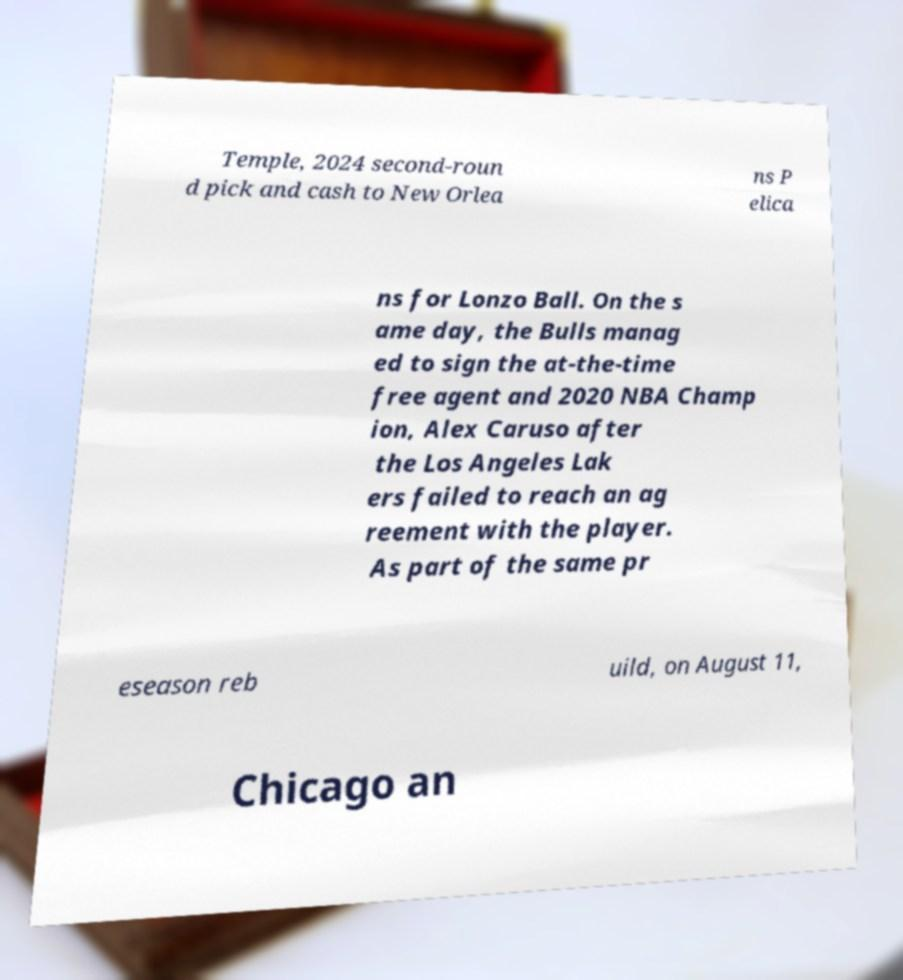What messages or text are displayed in this image? I need them in a readable, typed format. Temple, 2024 second-roun d pick and cash to New Orlea ns P elica ns for Lonzo Ball. On the s ame day, the Bulls manag ed to sign the at-the-time free agent and 2020 NBA Champ ion, Alex Caruso after the Los Angeles Lak ers failed to reach an ag reement with the player. As part of the same pr eseason reb uild, on August 11, Chicago an 